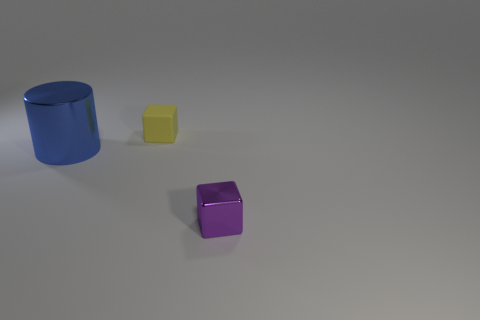Add 2 large shiny cylinders. How many objects exist? 5 Subtract all cylinders. How many objects are left? 2 Subtract all small purple metallic objects. Subtract all blue metal things. How many objects are left? 1 Add 1 blue cylinders. How many blue cylinders are left? 2 Add 1 small blocks. How many small blocks exist? 3 Subtract 0 gray cylinders. How many objects are left? 3 